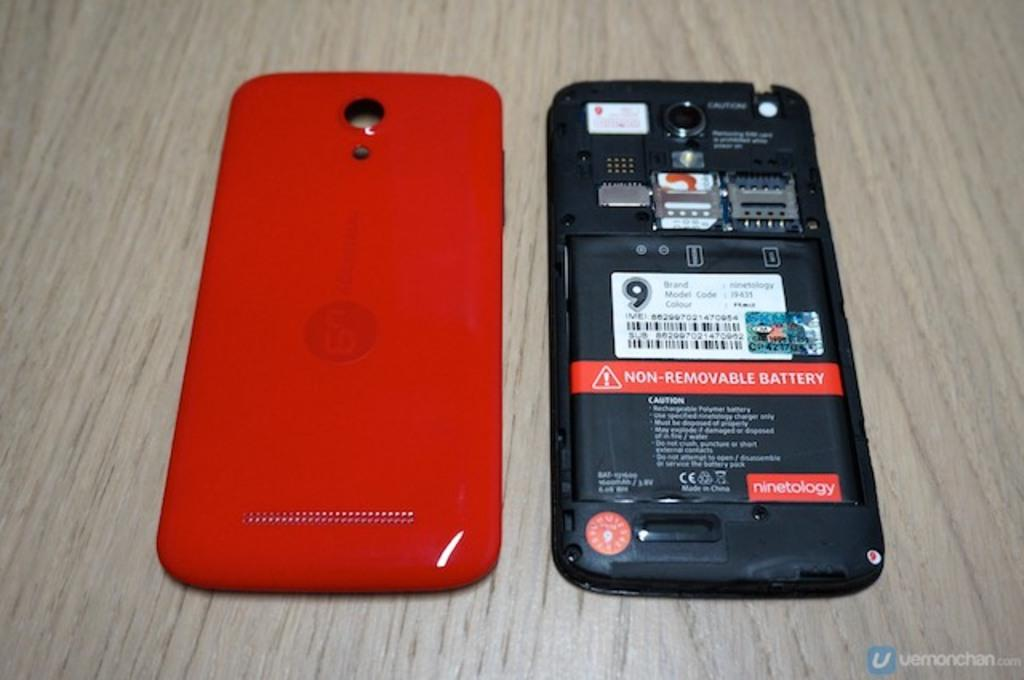Provide a one-sentence caption for the provided image. A red smart phone with the cover removed to show the non-removable battery. 